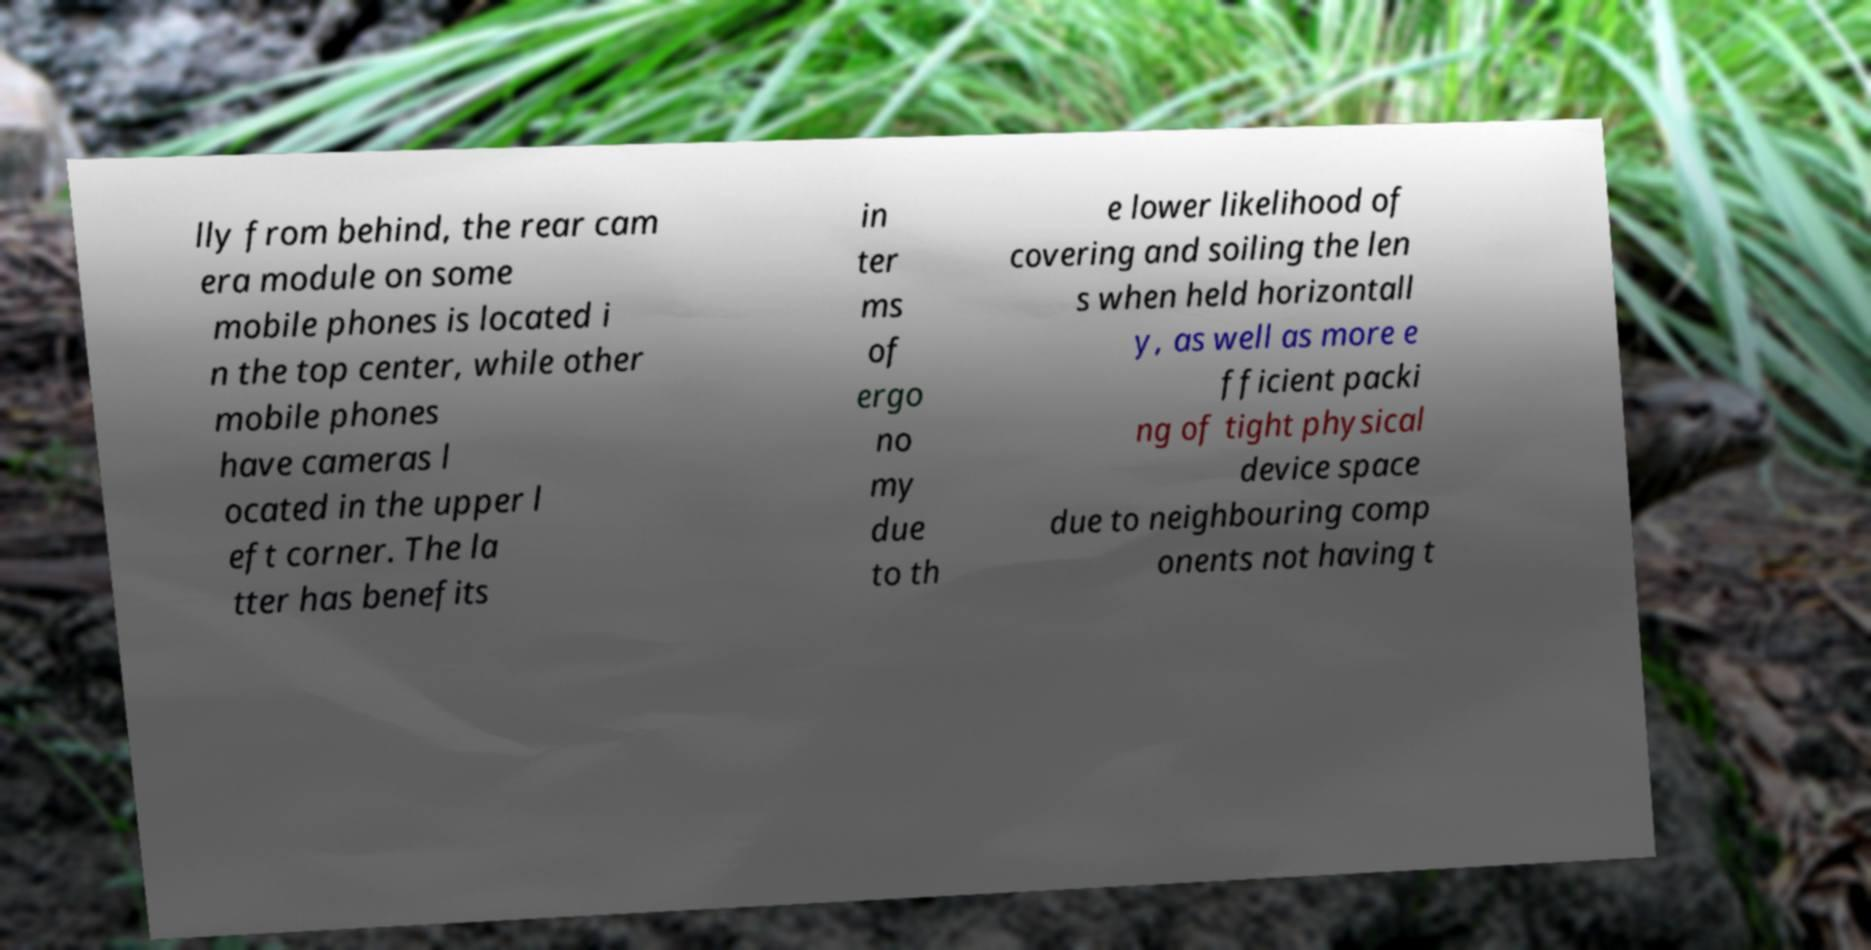Can you read and provide the text displayed in the image?This photo seems to have some interesting text. Can you extract and type it out for me? lly from behind, the rear cam era module on some mobile phones is located i n the top center, while other mobile phones have cameras l ocated in the upper l eft corner. The la tter has benefits in ter ms of ergo no my due to th e lower likelihood of covering and soiling the len s when held horizontall y, as well as more e fficient packi ng of tight physical device space due to neighbouring comp onents not having t 